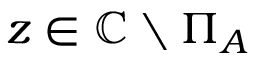Convert formula to latex. <formula><loc_0><loc_0><loc_500><loc_500>z \in \mathbb { C } \ \Pi _ { A }</formula> 